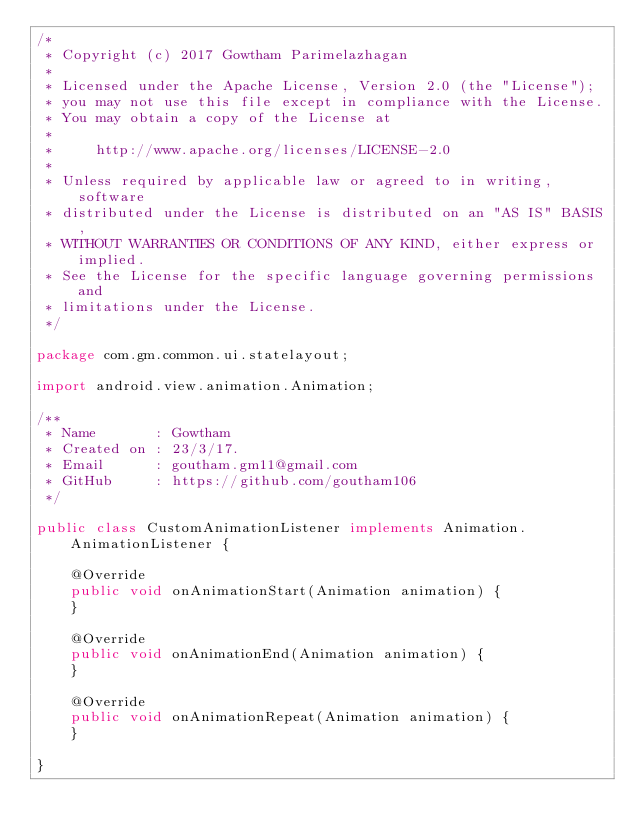<code> <loc_0><loc_0><loc_500><loc_500><_Java_>/*
 * Copyright (c) 2017 Gowtham Parimelazhagan
 *
 * Licensed under the Apache License, Version 2.0 (the "License");
 * you may not use this file except in compliance with the License.
 * You may obtain a copy of the License at
 *
 *     http://www.apache.org/licenses/LICENSE-2.0
 *
 * Unless required by applicable law or agreed to in writing, software
 * distributed under the License is distributed on an "AS IS" BASIS,
 * WITHOUT WARRANTIES OR CONDITIONS OF ANY KIND, either express or implied.
 * See the License for the specific language governing permissions and
 * limitations under the License.
 */

package com.gm.common.ui.statelayout;

import android.view.animation.Animation;

/**
 * Name       : Gowtham
 * Created on : 23/3/17.
 * Email      : goutham.gm11@gmail.com
 * GitHub     : https://github.com/goutham106
 */

public class CustomAnimationListener implements Animation.AnimationListener {

    @Override
    public void onAnimationStart(Animation animation) {
    }

    @Override
    public void onAnimationEnd(Animation animation) {
    }

    @Override
    public void onAnimationRepeat(Animation animation) {
    }

}
</code> 